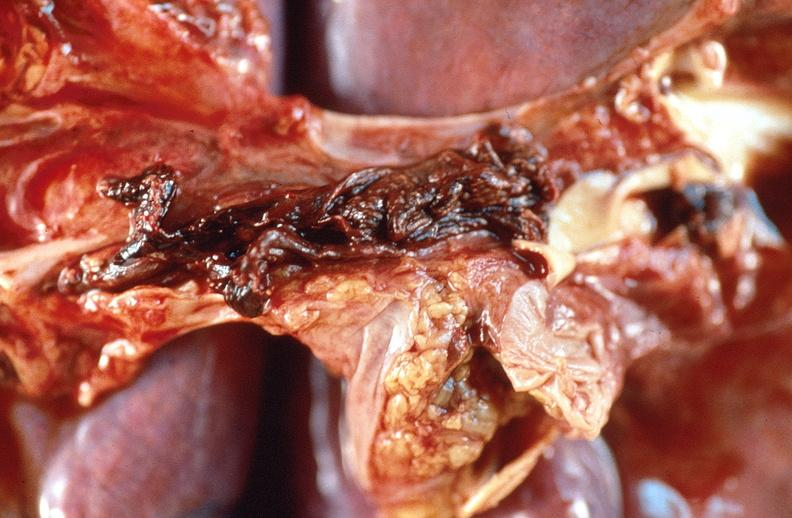s respiratory present?
Answer the question using a single word or phrase. Yes 